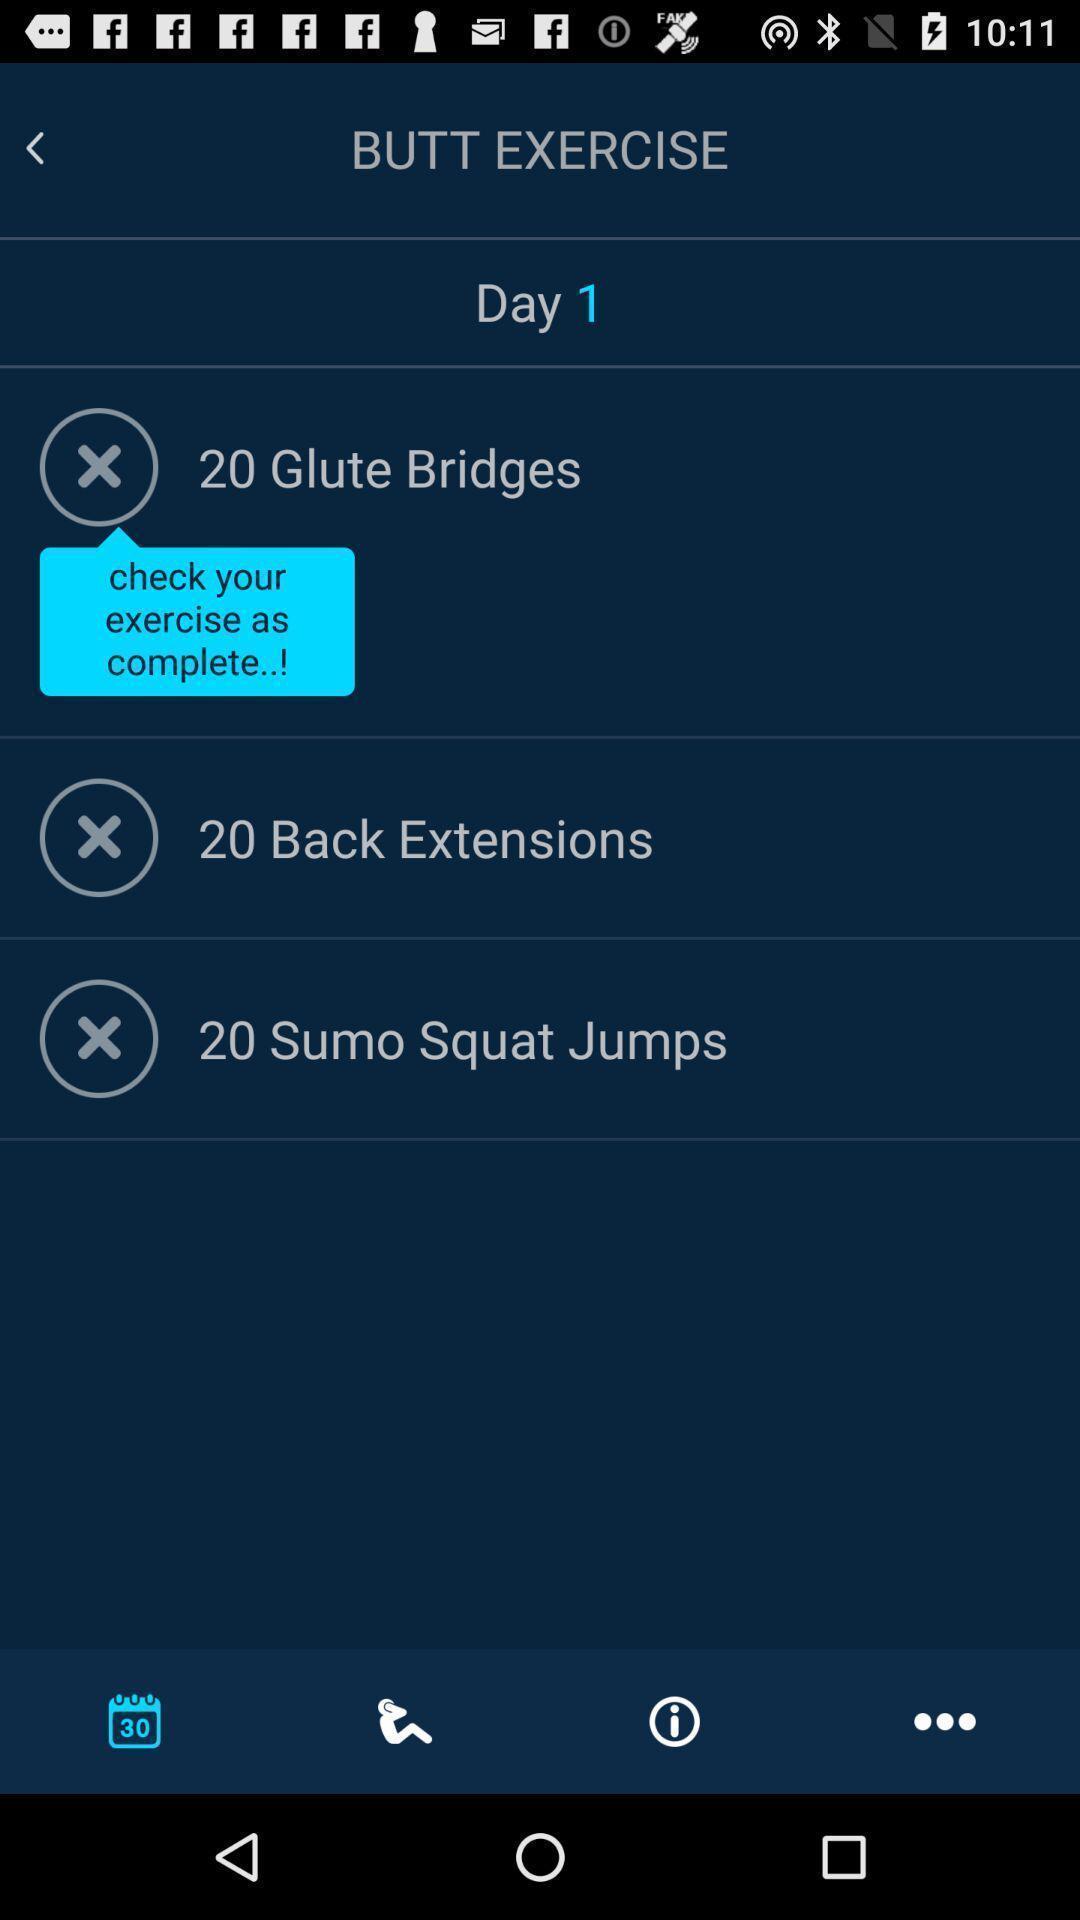What can you discern from this picture? Screen displaying the list of page in fitness app. 